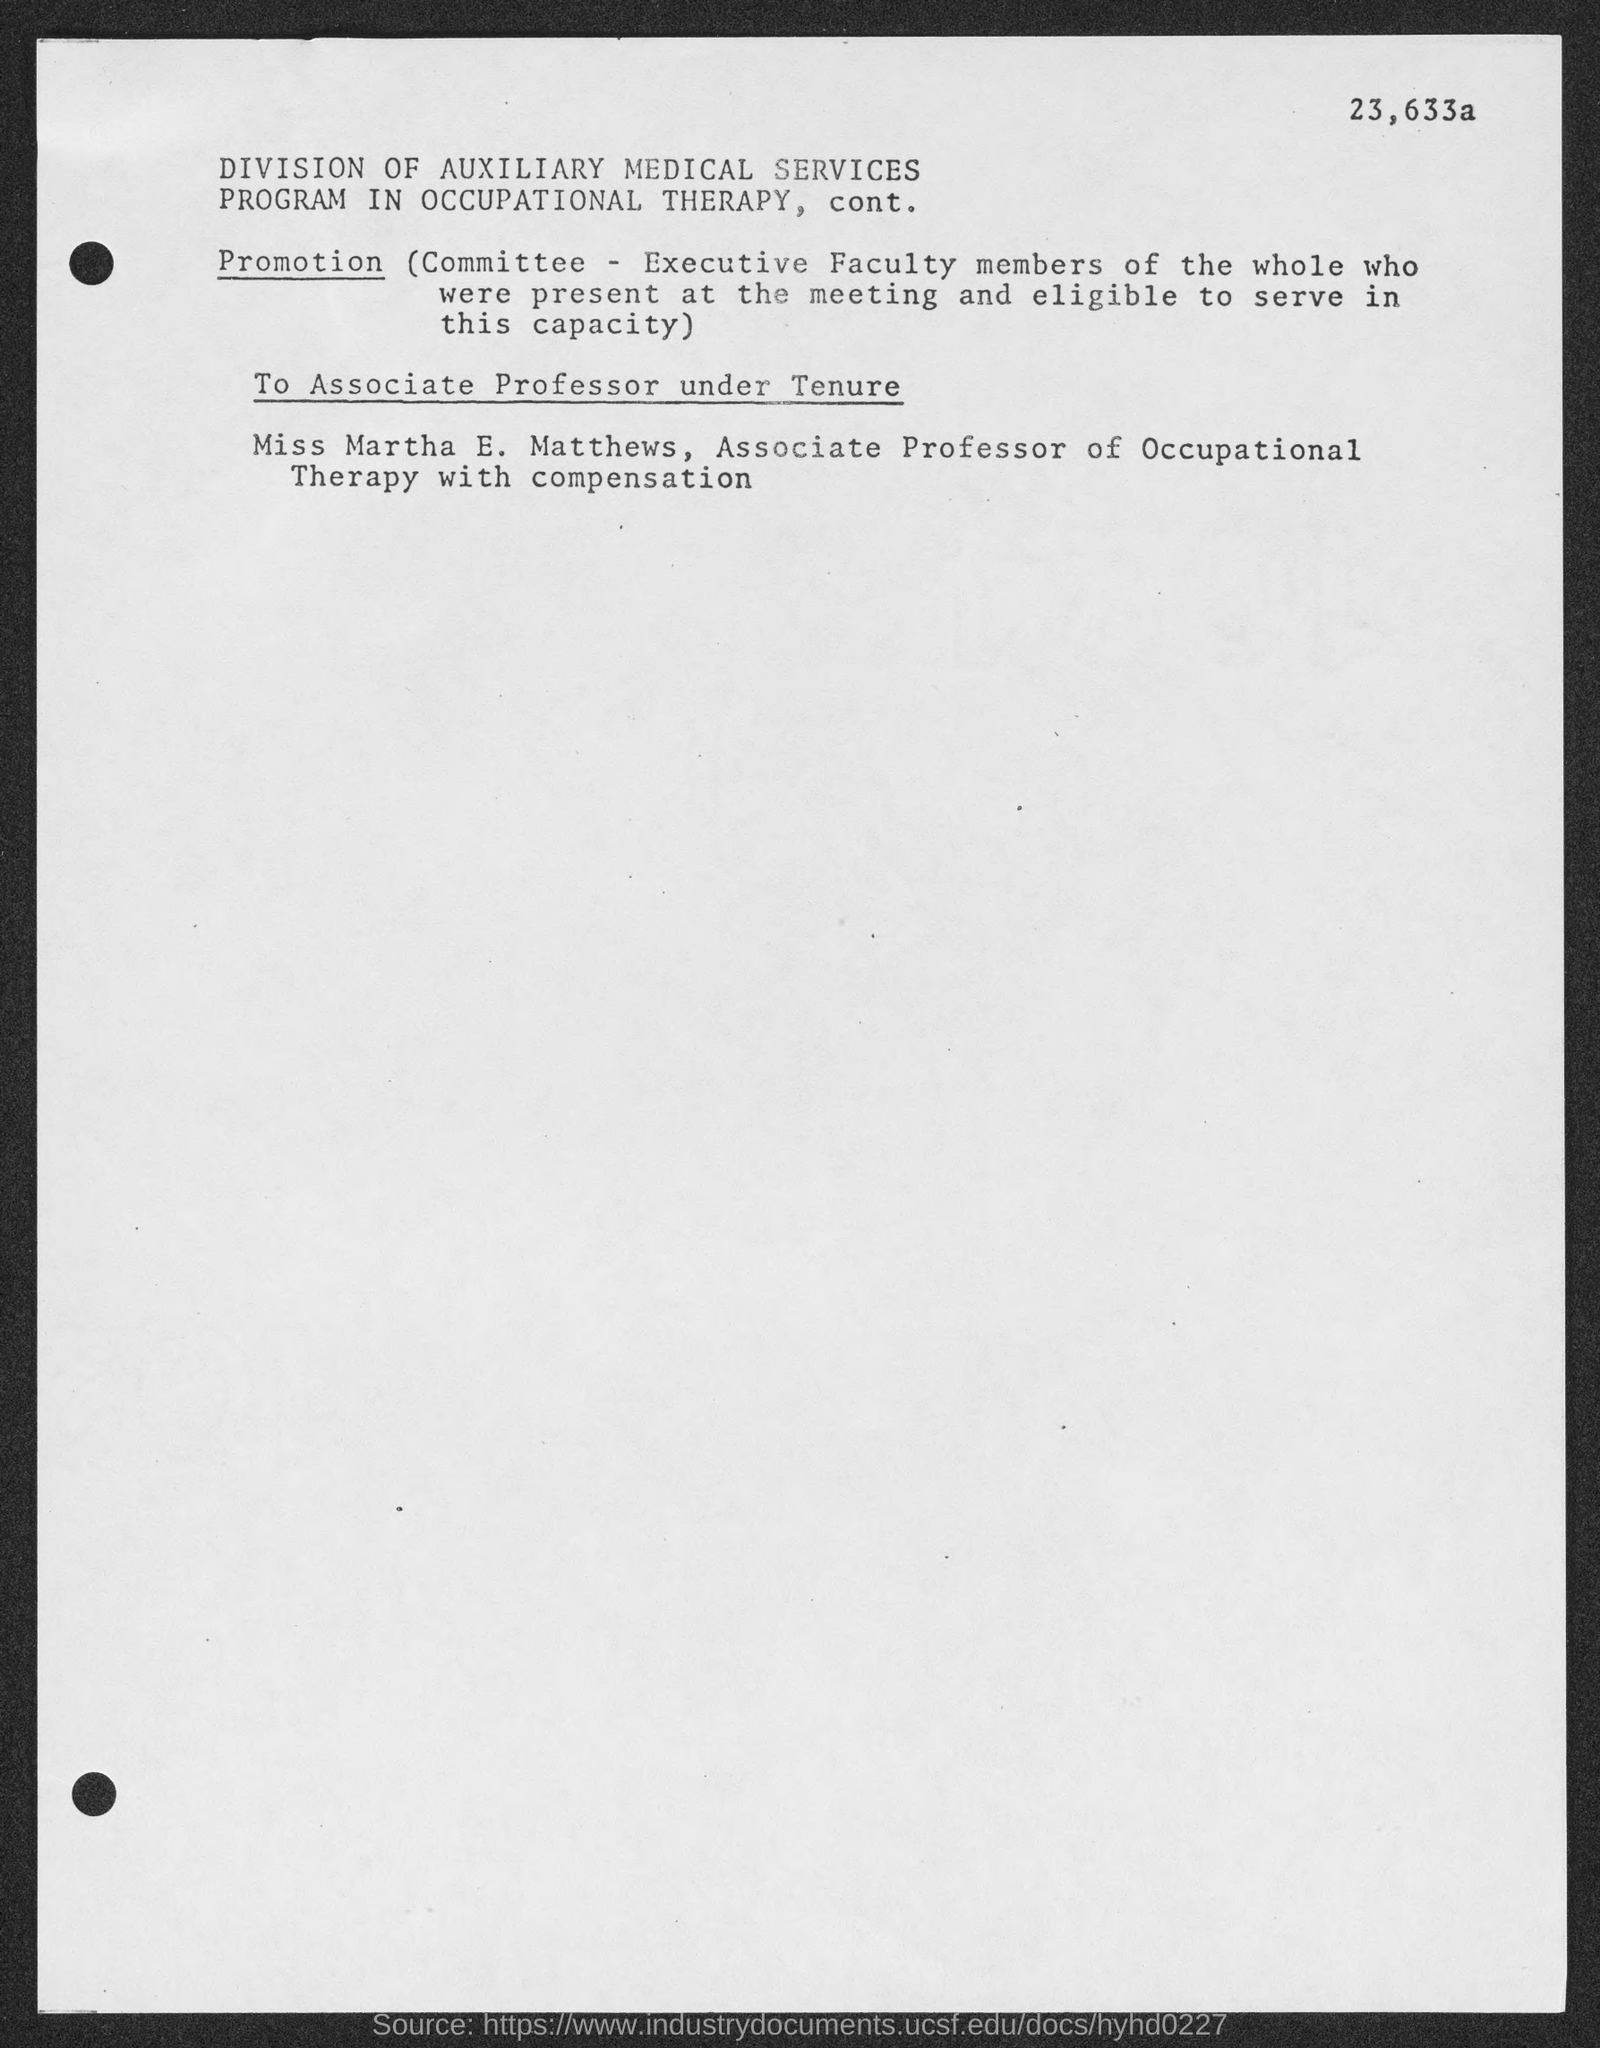Outline some significant characteristics in this image. Martha E. Matthews is an Associate Professor of Occupational Therapy and is compensated for her work. 